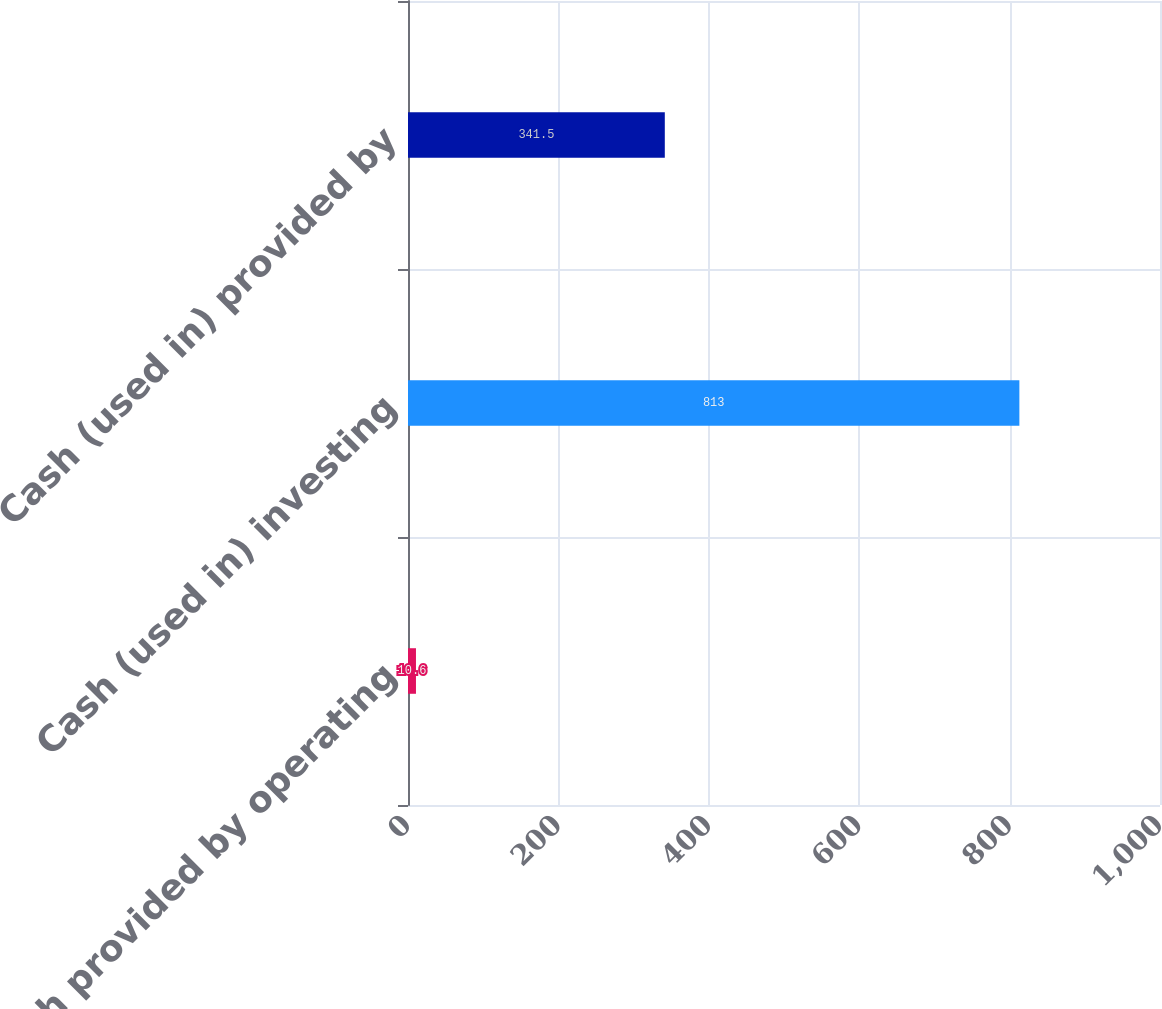<chart> <loc_0><loc_0><loc_500><loc_500><bar_chart><fcel>Cash provided by operating<fcel>Cash (used in) investing<fcel>Cash (used in) provided by<nl><fcel>10.6<fcel>813<fcel>341.5<nl></chart> 